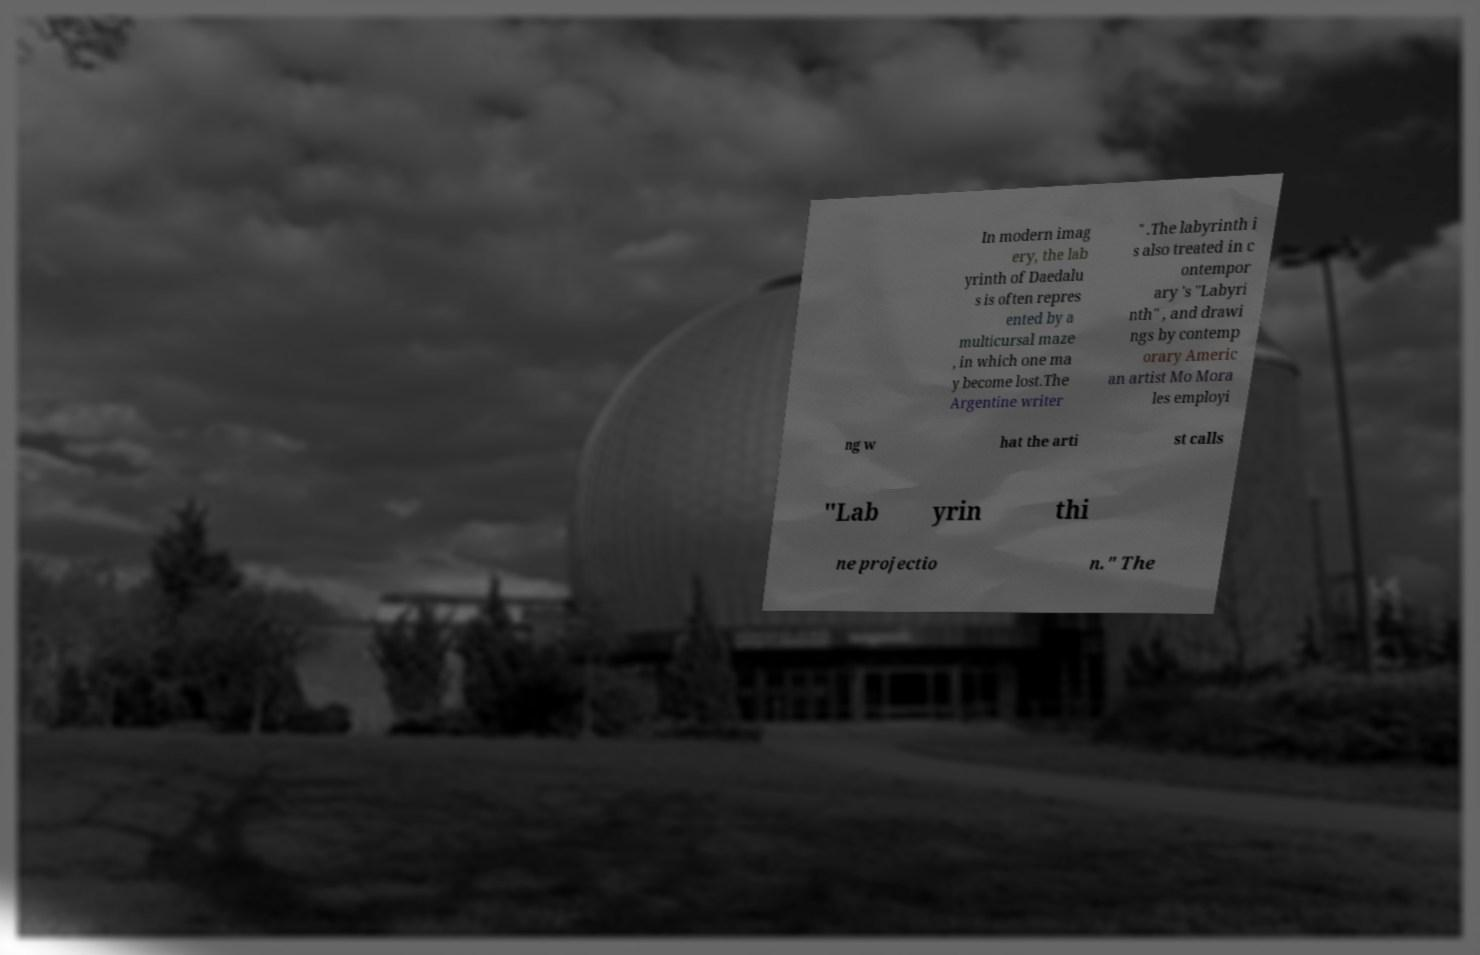Can you read and provide the text displayed in the image?This photo seems to have some interesting text. Can you extract and type it out for me? In modern imag ery, the lab yrinth of Daedalu s is often repres ented by a multicursal maze , in which one ma y become lost.The Argentine writer " .The labyrinth i s also treated in c ontempor ary 's "Labyri nth" , and drawi ngs by contemp orary Americ an artist Mo Mora les employi ng w hat the arti st calls "Lab yrin thi ne projectio n." The 